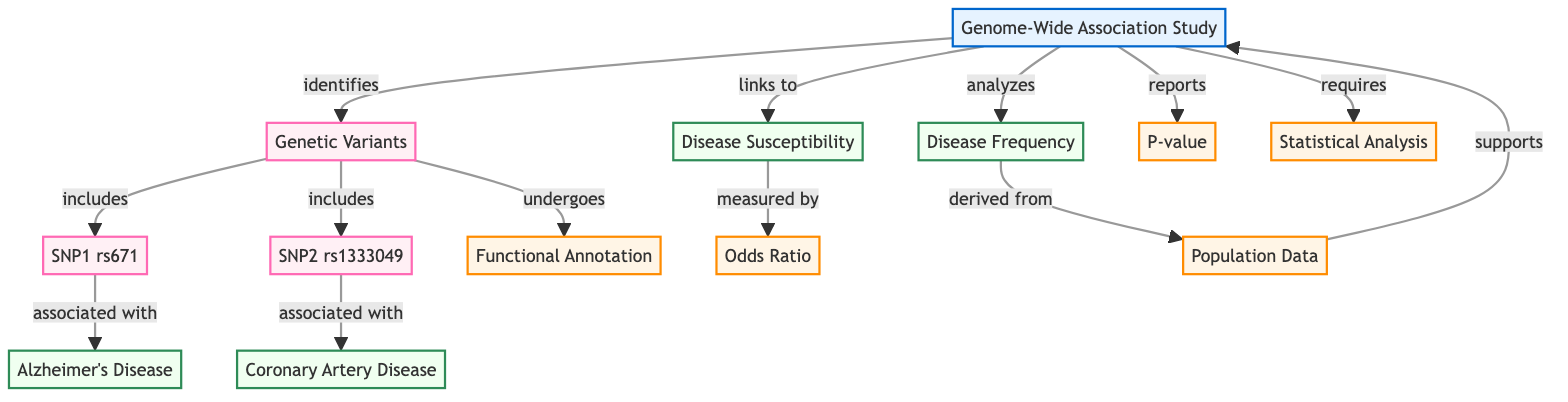What is the main focus of the diagram? The main focus of the diagram, as indicated by the title node, is "Genome-Wide Association Study". This is the central concept that connects various elements in the visual representation.
Answer: Genome-Wide Association Study How many genetic variants are referenced in the diagram? The diagram references two genetic variants: SNP1 rs671 and SNP2 rs1333049. Counting these nodes provides the total number of variants depicted in the diagram.
Answer: 2 What disease is SNP1 rs671 associated with? The diagram specifically states that SNP1 rs671 is associated with "Alzheimer's Disease", as indicated by the directed edge leading from SNP1 to this disease node.
Answer: Alzheimer's Disease What does "Disease Susceptibility" measure? According to the diagram, "Disease Susceptibility" is measured by "Odds Ratio", which is explicitly connected to the disease susceptibility node. This indicates the statistical relationship being measured.
Answer: Odds Ratio What is derived from "Population Data"? The arrow leading from "Population Data" to "Disease Frequency" indicates that disease frequency is the result of analysis based on population data. Hence, it shows the interdependence between these two elements.
Answer: Disease Frequency Which analysis method is required for the Genome-Wide Association Study? The diagram indicates that "Statistical Analysis" is required for conducting a Genome-Wide Association Study, connecting this analytical process directly to the main study node.
Answer: Statistical Analysis What type of genetic analysis undergoes "Functional Annotation"? The diagram shows that "Genetic Variants" undergo "Functional Annotation", suggesting that this type of analysis is applied to the genetic variants identified in the study.
Answer: Genetic Variants How is "Disease Frequency" analyzed? The diagram indicates that "Disease Frequency" is derived from "Population Data", which necessitates an analysis of population-level data to ascertain the frequency of the disease.
Answer: Population Data Which diseases are linked to the identified genetic variants in the diagram? The diagram illustrates that SNP1 rs671 is linked to "Alzheimer's Disease" and SNP2 rs1333049 is linked to "Coronary Artery Disease". This encompasses the diseases connected to the variants mentioned.
Answer: Alzheimer's Disease, Coronary Artery Disease 